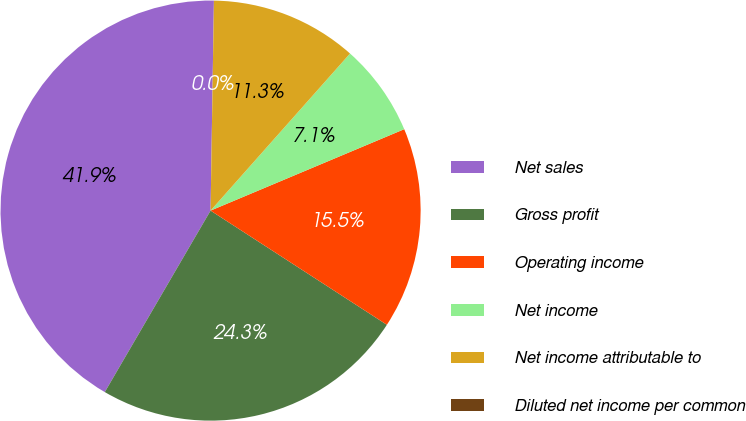Convert chart. <chart><loc_0><loc_0><loc_500><loc_500><pie_chart><fcel>Net sales<fcel>Gross profit<fcel>Operating income<fcel>Net income<fcel>Net income attributable to<fcel>Diluted net income per common<nl><fcel>41.85%<fcel>24.25%<fcel>15.48%<fcel>7.11%<fcel>11.3%<fcel>0.0%<nl></chart> 